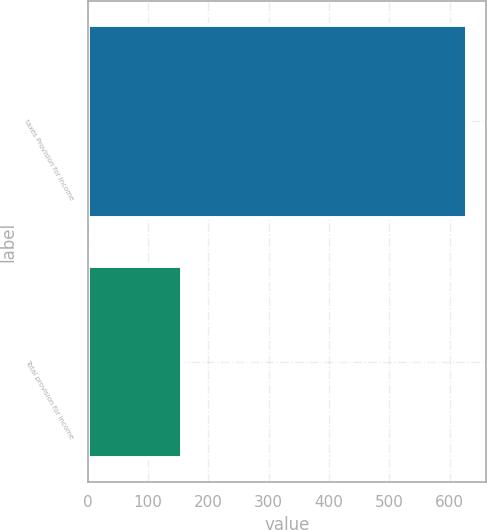Convert chart. <chart><loc_0><loc_0><loc_500><loc_500><bar_chart><fcel>taxes Provision for income<fcel>Total provision for income<nl><fcel>628.7<fcel>155.9<nl></chart> 